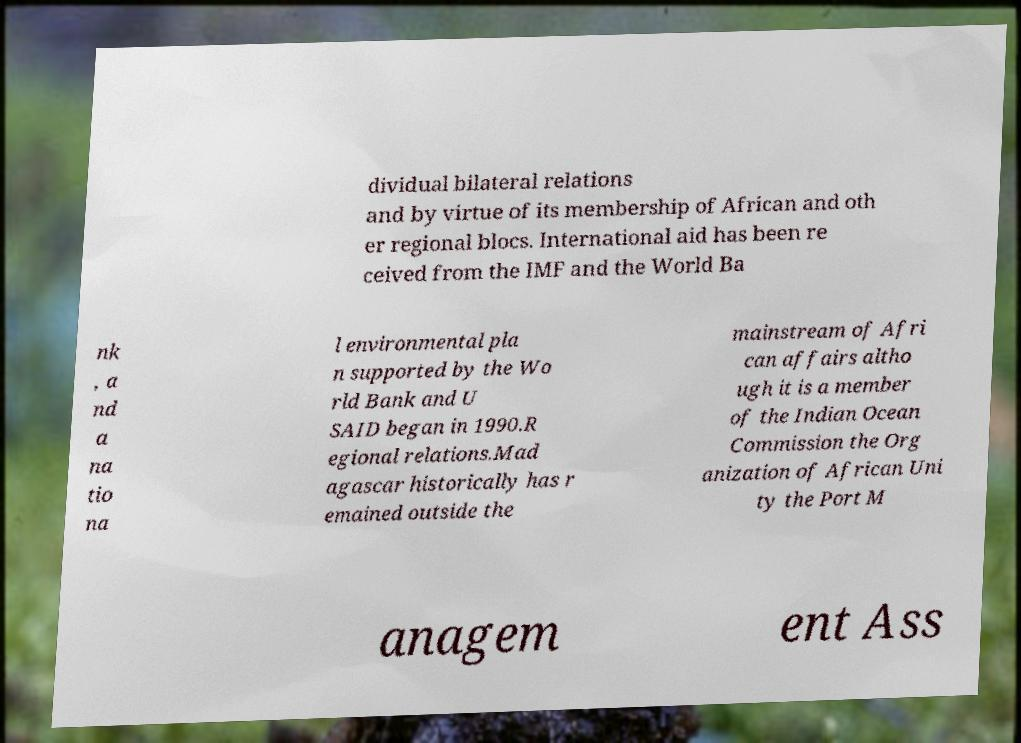Could you extract and type out the text from this image? dividual bilateral relations and by virtue of its membership of African and oth er regional blocs. International aid has been re ceived from the IMF and the World Ba nk , a nd a na tio na l environmental pla n supported by the Wo rld Bank and U SAID began in 1990.R egional relations.Mad agascar historically has r emained outside the mainstream of Afri can affairs altho ugh it is a member of the Indian Ocean Commission the Org anization of African Uni ty the Port M anagem ent Ass 